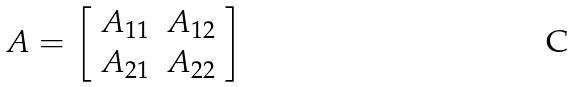Convert formula to latex. <formula><loc_0><loc_0><loc_500><loc_500>A = \left [ \begin{array} { c c } A _ { 1 1 } & A _ { 1 2 } \\ A _ { 2 1 } & A _ { 2 2 } \end{array} \right ]</formula> 